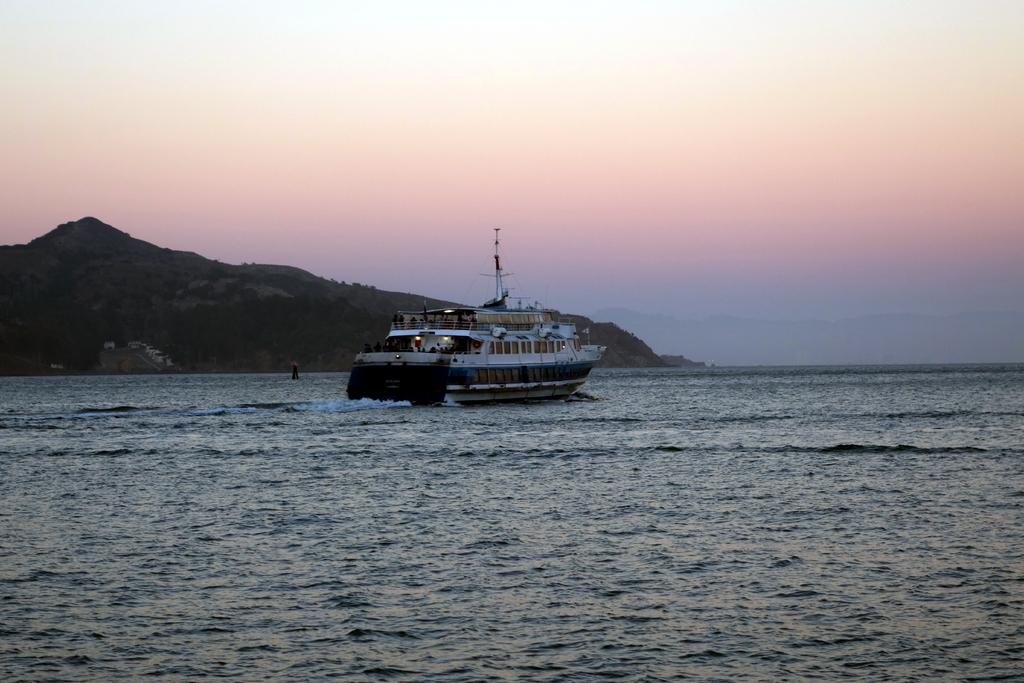What is located in the foreground of the picture? There is a water body in the foreground of the picture. What is the main subject in the center of the picture? There is a ship in the center of the picture. What can be seen in the background of the picture? There are trees and hills in the background of the picture. How many horses are pulling the ship in the image? There are no horses present in the image; the ship is not being pulled by any horses. What type of operation is being performed on the ship in the image? There is no operation being performed on the ship in the image; it is simply floating on the water. 